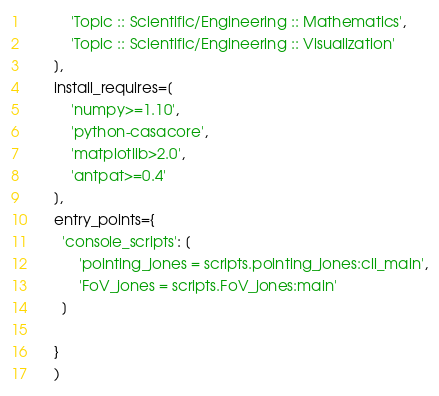Convert code to text. <code><loc_0><loc_0><loc_500><loc_500><_Python_>          'Topic :: Scientific/Engineering :: Mathematics',
          'Topic :: Scientific/Engineering :: Visualization'
      ],
      install_requires=[
          'numpy>=1.10',
          'python-casacore',
          'matplotlib>2.0',
          'antpat>=0.4'
      ],
      entry_points={
        'console_scripts': [
            'pointing_jones = scripts.pointing_jones:cli_main',
            'FoV_jones = scripts.FoV_jones:main'
        ]

      }
      )
</code> 